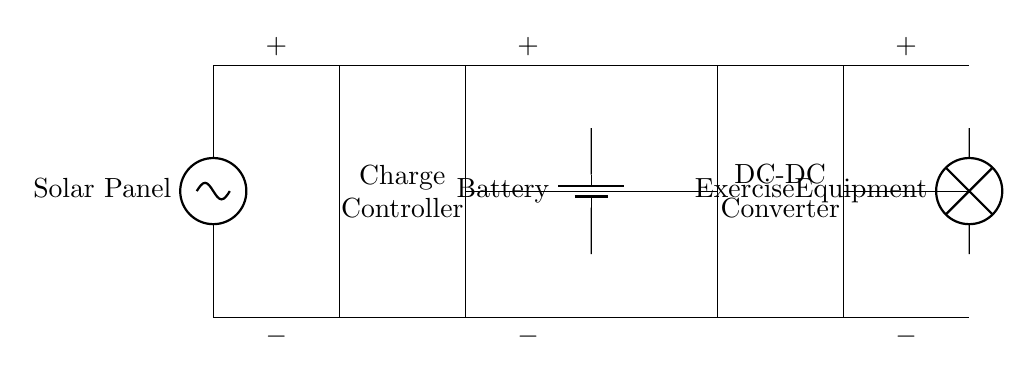What is the main power source in this circuit? The main power source is the solar panel located at the left side of the circuit diagram, which generates electricity from sunlight.
Answer: Solar Panel What component is used to regulate the voltage and current from the solar panel? The charge controller, represented as a rectangle in the circuit, regulates the voltage and current to ensure the battery is charged safely.
Answer: Charge Controller How many main components are involved in this solar charging circuit? The circuit includes four main components: the solar panel, charge controller, battery, and DC-DC converter.
Answer: Four What is the purpose of the DC-DC converter in this circuit? The DC-DC converter steps down or adjusts the voltage to match the needs of the exercise equipment, ensuring it operates correctly.
Answer: Adjust voltage What is the relationship between the battery and the charge controller? The charge controller manages the flow of energy to and from the battery, preventing overcharging and ensuring the battery's longevity.
Answer: Energy management What type of load is driven by this circuit? The load in this circuit is exercise equipment, indicated by the label next to it, which consumes the stored energy from the battery.
Answer: Exercise Equipment 